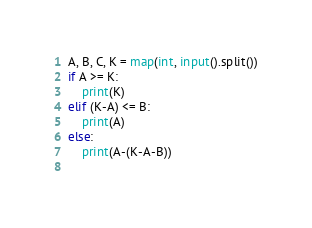<code> <loc_0><loc_0><loc_500><loc_500><_Python_>A, B, C, K = map(int, input().split())
if A >= K:
    print(K)
elif (K-A) <= B:
    print(A)
else:
    print(A-(K-A-B))
    </code> 